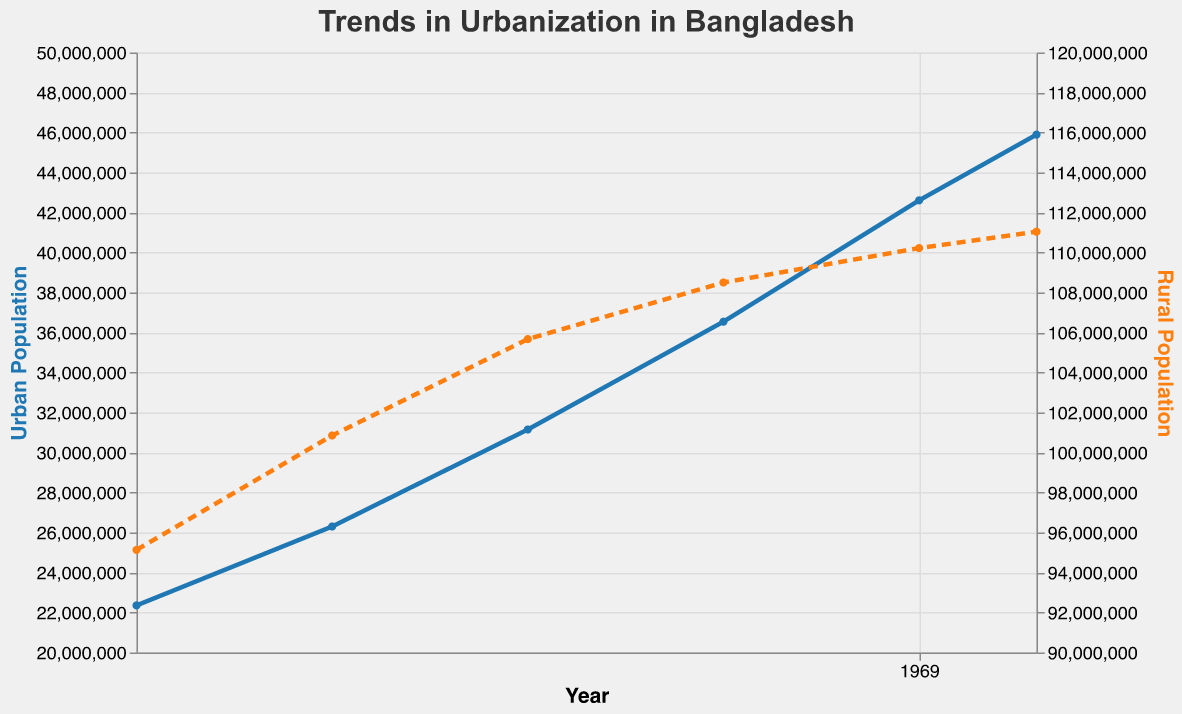What's the title of the figure? The title of the figure is displayed at the top and generally describes the overall content of the plot. The title in this case is "Trends in Urbanization in Bangladesh."
Answer: Trends in Urbanization in Bangladesh What is the color used for the Urban Population line? The color used for the Urban Population line is typically chosen to distinguish it clearly from other lines. In this case, the Urban Population line color is blue.
Answer: Blue How many data points are there for Rural Population? To find the number of data points for Rural Population, count the distinct marks or points along the orange dashed line. Each represents a different year in the dataset. There are six data points for Rural Population (2000, 2005, 2010, 2015, 2020, 2023).
Answer: 6 What is the value of the Urban Growth Rate in 2015? To find the Urban Growth Rate for a specific year, locate the year on the x-axis and then find the corresponding rate, usually given in annotations or the dataset. For 2015, the Urban Growth Rate is 2.85%.
Answer: 2.85% Which population, Urban or Rural, showed a greater growth rate decline from 2000 to 2023? Calculate the decline by subtracting the growth rate in 2023 from the growth rate in 2000 for both Urban and Rural populations. Urban Growth Rate decline: 3.56% - 2.33% = 1.23%. Rural Growth Rate decline: 1.21% - 0.34% = 0.87%. The Urban Growth Rate decline is greater.
Answer: Urban Population What can be inferred about the trends in rural and urban population sizes between 2000 and 2023? Look at the overall trends of the lines from 2000 to 2023. Urban Population consistently increases from 22,354,000 to 45,894,000. In contrast, Rural Population increases from 95,130,000 to 111,040,000 but at a slower pace and starts to plateau. The inference is that Urban Population is growing more rapidly while Rural Population growth is slowing down.
Answer: Urban population is growing faster, and Rural population growth is slowing down By how much did the Urban Population grow between 2000 and 2023? Subtract the Urban Population value in 2000 from the value in 2023: 45,894,000 - 22,354,000 = 23,540,000.
Answer: 23,540,000 What's the difference in Rural Population between 2010 and 2023? Subtract the Rural Population in 2010 from that in 2023: 111,040,000 - 105,670,000 = 5,370,000.
Answer: 5,370,000 Is there any year where the growth rate of the Rural Population was higher than the Urban Growth Rate? Compare the Urban and Rural Growth Rates year by year. There is no year where the Rural Growth Rate exceeds the Urban Growth Rate.
Answer: No Based on the trends, what prediction can you make about the population distribution in the future? Observing the continued increase in Urban Population and the plateauing of Rural Population, one can predict that the majority of population growth will continue to occur in urban areas, likely leading to higher urbanization rates in the future.
Answer: More growth in urban areas 